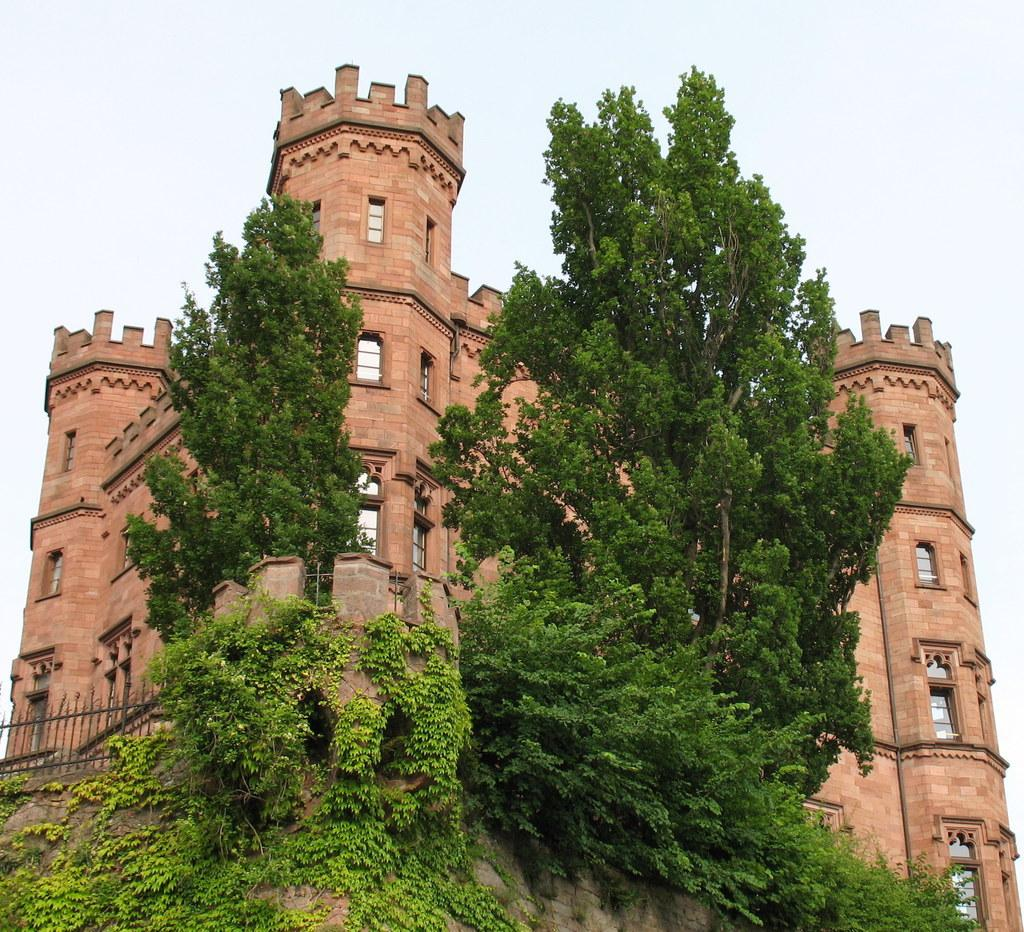What type of structure is present in the image? There is a building in the image. What feature of the building is mentioned in the facts? The building has many windows. What natural elements can be seen in the image? There are two trees and many plants in the image. What type of barrier is present in the image? There is a fencing in the image. What part of the natural environment is visible in the image? The sky is visible in the image. What type of cactus is being used as a prop by the farmer in the image? There is no cactus or farmer present in the image. How does the twist in the fencing affect the overall appearance of the image? There is no mention of a twist in the fencing in the provided facts, so we cannot answer this question. 